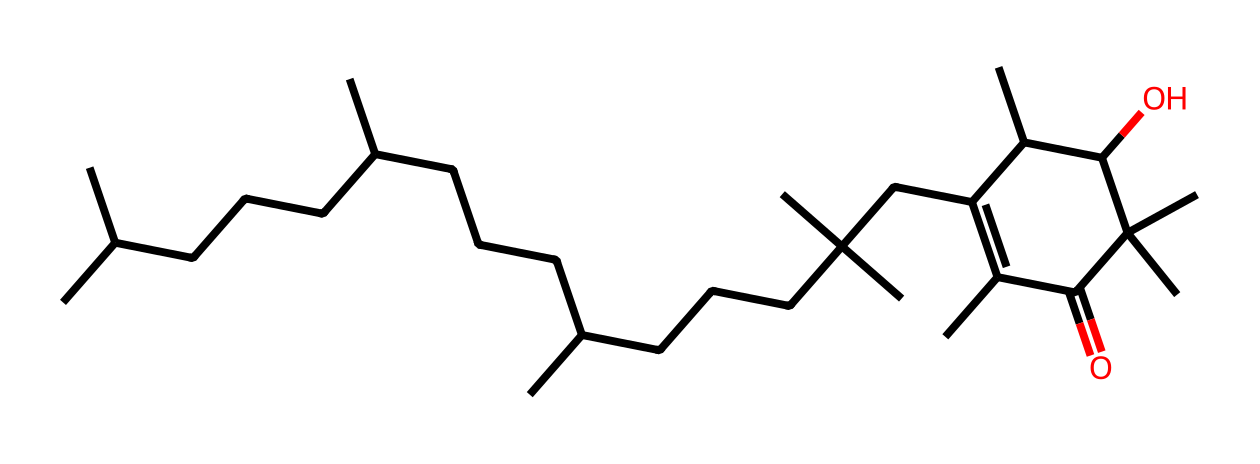What type of vitamin is represented by this chemical structure? The provided chemical structure corresponds to Vitamin E, specifically tocopherol, based on its common structural features and functional groups.
Answer: Vitamin E How many carbon atoms are in this chemical? By analyzing the structure, the total number of carbon (C) atoms in the molecule can be counted, which is 40.
Answer: 40 What functional group is primarily responsible for the antioxidant properties of Vitamin E? The presence of hydroxyl (–OH) groups in the structure contributes to the antioxidant properties, as this group is capable of donating electrons.
Answer: hydroxyl group What is the molecular formula of the compound represented by the SMILES? To derive the molecular formula, one must count the atoms: there are 40 carbons, 66 hydrogens, and 1 oxygen, leading to the formula C40H66O.
Answer: C40H66O What type of fatty acids are abundant in sunflower oil, which help Vitamin E dissolve? Sunflower oil is rich in unsaturated fatty acids, which promote the solubility and absorption of Vitamin E in the body.
Answer: unsaturated fatty acids Which part of the molecule allows it to integrate into cell membranes? The long hydrocarbon chains of the molecule enable it to be lipid-soluble, allowing integration into the phospholipid bilayer of cell membranes.
Answer: hydrocarbon chains 